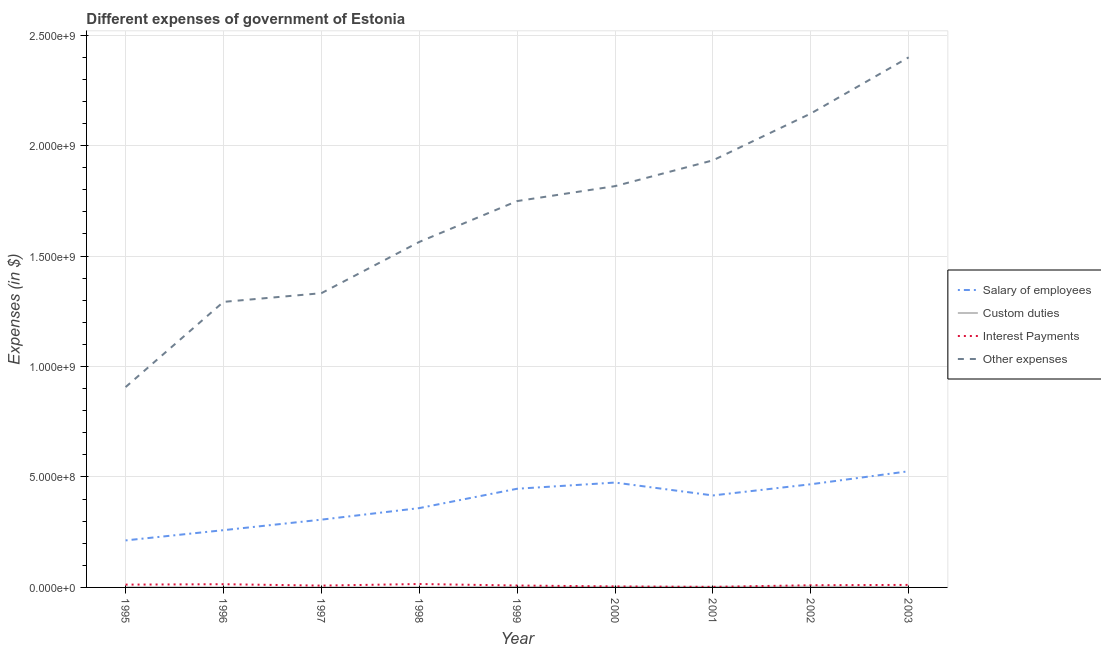How many different coloured lines are there?
Provide a succinct answer. 4. What is the amount spent on other expenses in 1995?
Offer a terse response. 9.07e+08. Across all years, what is the maximum amount spent on interest payments?
Provide a short and direct response. 1.54e+07. Across all years, what is the minimum amount spent on other expenses?
Make the answer very short. 9.07e+08. In which year was the amount spent on custom duties maximum?
Your answer should be very brief. 2002. In which year was the amount spent on custom duties minimum?
Your response must be concise. 1998. What is the total amount spent on custom duties in the graph?
Keep it short and to the point. 1.20e+07. What is the difference between the amount spent on other expenses in 1996 and that in 2000?
Offer a terse response. -5.24e+08. What is the difference between the amount spent on custom duties in 2002 and the amount spent on salary of employees in 1997?
Provide a succinct answer. -3.03e+08. What is the average amount spent on salary of employees per year?
Offer a terse response. 3.85e+08. In the year 2000, what is the difference between the amount spent on salary of employees and amount spent on other expenses?
Provide a succinct answer. -1.34e+09. In how many years, is the amount spent on interest payments greater than 800000000 $?
Keep it short and to the point. 0. What is the ratio of the amount spent on other expenses in 1996 to that in 1998?
Keep it short and to the point. 0.83. What is the difference between the highest and the second highest amount spent on custom duties?
Make the answer very short. 8.50e+05. What is the difference between the highest and the lowest amount spent on other expenses?
Give a very brief answer. 1.49e+09. Is it the case that in every year, the sum of the amount spent on salary of employees and amount spent on interest payments is greater than the sum of amount spent on custom duties and amount spent on other expenses?
Your answer should be very brief. No. Is it the case that in every year, the sum of the amount spent on salary of employees and amount spent on custom duties is greater than the amount spent on interest payments?
Make the answer very short. Yes. Does the amount spent on other expenses monotonically increase over the years?
Your answer should be very brief. Yes. Is the amount spent on interest payments strictly less than the amount spent on other expenses over the years?
Provide a short and direct response. Yes. How many lines are there?
Keep it short and to the point. 4. How many years are there in the graph?
Keep it short and to the point. 9. What is the difference between two consecutive major ticks on the Y-axis?
Make the answer very short. 5.00e+08. Are the values on the major ticks of Y-axis written in scientific E-notation?
Your answer should be very brief. Yes. Does the graph contain grids?
Offer a terse response. Yes. Where does the legend appear in the graph?
Your answer should be compact. Center right. What is the title of the graph?
Make the answer very short. Different expenses of government of Estonia. Does "Primary schools" appear as one of the legend labels in the graph?
Give a very brief answer. No. What is the label or title of the X-axis?
Your answer should be compact. Year. What is the label or title of the Y-axis?
Provide a succinct answer. Expenses (in $). What is the Expenses (in $) of Salary of employees in 1995?
Provide a short and direct response. 2.13e+08. What is the Expenses (in $) of Interest Payments in 1995?
Ensure brevity in your answer.  1.27e+07. What is the Expenses (in $) in Other expenses in 1995?
Give a very brief answer. 9.07e+08. What is the Expenses (in $) of Salary of employees in 1996?
Provide a succinct answer. 2.59e+08. What is the Expenses (in $) of Interest Payments in 1996?
Provide a succinct answer. 1.45e+07. What is the Expenses (in $) in Other expenses in 1996?
Your response must be concise. 1.29e+09. What is the Expenses (in $) in Salary of employees in 1997?
Keep it short and to the point. 3.07e+08. What is the Expenses (in $) of Custom duties in 1997?
Your answer should be compact. 4.00e+04. What is the Expenses (in $) in Interest Payments in 1997?
Give a very brief answer. 8.30e+06. What is the Expenses (in $) in Other expenses in 1997?
Give a very brief answer. 1.33e+09. What is the Expenses (in $) of Salary of employees in 1998?
Your answer should be very brief. 3.59e+08. What is the Expenses (in $) in Custom duties in 1998?
Make the answer very short. 10000. What is the Expenses (in $) of Interest Payments in 1998?
Give a very brief answer. 1.54e+07. What is the Expenses (in $) of Other expenses in 1998?
Give a very brief answer. 1.56e+09. What is the Expenses (in $) of Salary of employees in 1999?
Keep it short and to the point. 4.47e+08. What is the Expenses (in $) in Custom duties in 1999?
Your answer should be very brief. 2.26e+06. What is the Expenses (in $) of Interest Payments in 1999?
Ensure brevity in your answer.  8.70e+06. What is the Expenses (in $) in Other expenses in 1999?
Make the answer very short. 1.75e+09. What is the Expenses (in $) of Salary of employees in 2000?
Give a very brief answer. 4.75e+08. What is the Expenses (in $) in Custom duties in 2000?
Ensure brevity in your answer.  2.56e+06. What is the Expenses (in $) in Interest Payments in 2000?
Give a very brief answer. 4.60e+06. What is the Expenses (in $) of Other expenses in 2000?
Provide a succinct answer. 1.82e+09. What is the Expenses (in $) in Salary of employees in 2001?
Offer a very short reply. 4.16e+08. What is the Expenses (in $) in Custom duties in 2001?
Your response must be concise. 2.45e+06. What is the Expenses (in $) of Interest Payments in 2001?
Offer a terse response. 2.60e+06. What is the Expenses (in $) of Other expenses in 2001?
Ensure brevity in your answer.  1.93e+09. What is the Expenses (in $) of Salary of employees in 2002?
Provide a succinct answer. 4.67e+08. What is the Expenses (in $) in Custom duties in 2002?
Keep it short and to the point. 3.41e+06. What is the Expenses (in $) of Interest Payments in 2002?
Make the answer very short. 1.00e+07. What is the Expenses (in $) of Other expenses in 2002?
Your answer should be compact. 2.15e+09. What is the Expenses (in $) in Salary of employees in 2003?
Your answer should be very brief. 5.26e+08. What is the Expenses (in $) of Custom duties in 2003?
Your answer should be compact. 7.80e+05. What is the Expenses (in $) in Interest Payments in 2003?
Provide a succinct answer. 1.14e+07. What is the Expenses (in $) of Other expenses in 2003?
Your response must be concise. 2.40e+09. Across all years, what is the maximum Expenses (in $) of Salary of employees?
Your answer should be compact. 5.26e+08. Across all years, what is the maximum Expenses (in $) in Custom duties?
Your answer should be compact. 3.41e+06. Across all years, what is the maximum Expenses (in $) of Interest Payments?
Your response must be concise. 1.54e+07. Across all years, what is the maximum Expenses (in $) of Other expenses?
Offer a terse response. 2.40e+09. Across all years, what is the minimum Expenses (in $) in Salary of employees?
Provide a short and direct response. 2.13e+08. Across all years, what is the minimum Expenses (in $) in Custom duties?
Provide a succinct answer. 10000. Across all years, what is the minimum Expenses (in $) of Interest Payments?
Give a very brief answer. 2.60e+06. Across all years, what is the minimum Expenses (in $) in Other expenses?
Your answer should be compact. 9.07e+08. What is the total Expenses (in $) in Salary of employees in the graph?
Your answer should be very brief. 3.47e+09. What is the total Expenses (in $) in Custom duties in the graph?
Offer a terse response. 1.20e+07. What is the total Expenses (in $) of Interest Payments in the graph?
Your response must be concise. 8.82e+07. What is the total Expenses (in $) of Other expenses in the graph?
Provide a short and direct response. 1.51e+1. What is the difference between the Expenses (in $) in Salary of employees in 1995 and that in 1996?
Ensure brevity in your answer.  -4.64e+07. What is the difference between the Expenses (in $) in Interest Payments in 1995 and that in 1996?
Offer a terse response. -1.80e+06. What is the difference between the Expenses (in $) in Other expenses in 1995 and that in 1996?
Your answer should be very brief. -3.86e+08. What is the difference between the Expenses (in $) of Salary of employees in 1995 and that in 1997?
Your response must be concise. -9.40e+07. What is the difference between the Expenses (in $) in Custom duties in 1995 and that in 1997?
Provide a succinct answer. 4.60e+05. What is the difference between the Expenses (in $) in Interest Payments in 1995 and that in 1997?
Your response must be concise. 4.40e+06. What is the difference between the Expenses (in $) of Other expenses in 1995 and that in 1997?
Keep it short and to the point. -4.25e+08. What is the difference between the Expenses (in $) in Salary of employees in 1995 and that in 1998?
Offer a terse response. -1.46e+08. What is the difference between the Expenses (in $) of Custom duties in 1995 and that in 1998?
Provide a succinct answer. 4.90e+05. What is the difference between the Expenses (in $) in Interest Payments in 1995 and that in 1998?
Your answer should be very brief. -2.70e+06. What is the difference between the Expenses (in $) of Other expenses in 1995 and that in 1998?
Offer a very short reply. -6.57e+08. What is the difference between the Expenses (in $) of Salary of employees in 1995 and that in 1999?
Keep it short and to the point. -2.34e+08. What is the difference between the Expenses (in $) of Custom duties in 1995 and that in 1999?
Provide a succinct answer. -1.76e+06. What is the difference between the Expenses (in $) of Other expenses in 1995 and that in 1999?
Give a very brief answer. -8.42e+08. What is the difference between the Expenses (in $) of Salary of employees in 1995 and that in 2000?
Ensure brevity in your answer.  -2.62e+08. What is the difference between the Expenses (in $) of Custom duties in 1995 and that in 2000?
Offer a very short reply. -2.06e+06. What is the difference between the Expenses (in $) in Interest Payments in 1995 and that in 2000?
Keep it short and to the point. 8.10e+06. What is the difference between the Expenses (in $) of Other expenses in 1995 and that in 2000?
Keep it short and to the point. -9.10e+08. What is the difference between the Expenses (in $) of Salary of employees in 1995 and that in 2001?
Make the answer very short. -2.04e+08. What is the difference between the Expenses (in $) in Custom duties in 1995 and that in 2001?
Offer a very short reply. -1.95e+06. What is the difference between the Expenses (in $) in Interest Payments in 1995 and that in 2001?
Make the answer very short. 1.01e+07. What is the difference between the Expenses (in $) of Other expenses in 1995 and that in 2001?
Keep it short and to the point. -1.03e+09. What is the difference between the Expenses (in $) in Salary of employees in 1995 and that in 2002?
Your response must be concise. -2.54e+08. What is the difference between the Expenses (in $) in Custom duties in 1995 and that in 2002?
Your answer should be very brief. -2.91e+06. What is the difference between the Expenses (in $) in Interest Payments in 1995 and that in 2002?
Your answer should be very brief. 2.70e+06. What is the difference between the Expenses (in $) of Other expenses in 1995 and that in 2002?
Offer a very short reply. -1.24e+09. What is the difference between the Expenses (in $) of Salary of employees in 1995 and that in 2003?
Give a very brief answer. -3.13e+08. What is the difference between the Expenses (in $) in Custom duties in 1995 and that in 2003?
Your answer should be very brief. -2.80e+05. What is the difference between the Expenses (in $) in Interest Payments in 1995 and that in 2003?
Keep it short and to the point. 1.30e+06. What is the difference between the Expenses (in $) of Other expenses in 1995 and that in 2003?
Ensure brevity in your answer.  -1.49e+09. What is the difference between the Expenses (in $) in Salary of employees in 1996 and that in 1997?
Provide a short and direct response. -4.76e+07. What is the difference between the Expenses (in $) in Custom duties in 1996 and that in 1997?
Offer a very short reply. -10000. What is the difference between the Expenses (in $) of Interest Payments in 1996 and that in 1997?
Provide a succinct answer. 6.20e+06. What is the difference between the Expenses (in $) in Other expenses in 1996 and that in 1997?
Offer a very short reply. -3.93e+07. What is the difference between the Expenses (in $) of Salary of employees in 1996 and that in 1998?
Make the answer very short. -9.99e+07. What is the difference between the Expenses (in $) of Custom duties in 1996 and that in 1998?
Provide a succinct answer. 2.00e+04. What is the difference between the Expenses (in $) in Interest Payments in 1996 and that in 1998?
Provide a short and direct response. -9.00e+05. What is the difference between the Expenses (in $) of Other expenses in 1996 and that in 1998?
Your response must be concise. -2.71e+08. What is the difference between the Expenses (in $) in Salary of employees in 1996 and that in 1999?
Your response must be concise. -1.88e+08. What is the difference between the Expenses (in $) in Custom duties in 1996 and that in 1999?
Keep it short and to the point. -2.23e+06. What is the difference between the Expenses (in $) in Interest Payments in 1996 and that in 1999?
Your response must be concise. 5.80e+06. What is the difference between the Expenses (in $) of Other expenses in 1996 and that in 1999?
Your response must be concise. -4.56e+08. What is the difference between the Expenses (in $) of Salary of employees in 1996 and that in 2000?
Provide a short and direct response. -2.16e+08. What is the difference between the Expenses (in $) of Custom duties in 1996 and that in 2000?
Keep it short and to the point. -2.53e+06. What is the difference between the Expenses (in $) in Interest Payments in 1996 and that in 2000?
Give a very brief answer. 9.90e+06. What is the difference between the Expenses (in $) of Other expenses in 1996 and that in 2000?
Offer a terse response. -5.24e+08. What is the difference between the Expenses (in $) in Salary of employees in 1996 and that in 2001?
Provide a succinct answer. -1.57e+08. What is the difference between the Expenses (in $) of Custom duties in 1996 and that in 2001?
Offer a terse response. -2.42e+06. What is the difference between the Expenses (in $) in Interest Payments in 1996 and that in 2001?
Make the answer very short. 1.19e+07. What is the difference between the Expenses (in $) of Other expenses in 1996 and that in 2001?
Ensure brevity in your answer.  -6.41e+08. What is the difference between the Expenses (in $) of Salary of employees in 1996 and that in 2002?
Your answer should be compact. -2.08e+08. What is the difference between the Expenses (in $) of Custom duties in 1996 and that in 2002?
Ensure brevity in your answer.  -3.38e+06. What is the difference between the Expenses (in $) in Interest Payments in 1996 and that in 2002?
Offer a very short reply. 4.50e+06. What is the difference between the Expenses (in $) of Other expenses in 1996 and that in 2002?
Ensure brevity in your answer.  -8.53e+08. What is the difference between the Expenses (in $) of Salary of employees in 1996 and that in 2003?
Your answer should be compact. -2.67e+08. What is the difference between the Expenses (in $) of Custom duties in 1996 and that in 2003?
Your answer should be compact. -7.50e+05. What is the difference between the Expenses (in $) in Interest Payments in 1996 and that in 2003?
Your answer should be compact. 3.10e+06. What is the difference between the Expenses (in $) of Other expenses in 1996 and that in 2003?
Provide a succinct answer. -1.11e+09. What is the difference between the Expenses (in $) of Salary of employees in 1997 and that in 1998?
Provide a succinct answer. -5.23e+07. What is the difference between the Expenses (in $) of Interest Payments in 1997 and that in 1998?
Make the answer very short. -7.10e+06. What is the difference between the Expenses (in $) of Other expenses in 1997 and that in 1998?
Your answer should be very brief. -2.32e+08. What is the difference between the Expenses (in $) of Salary of employees in 1997 and that in 1999?
Offer a very short reply. -1.40e+08. What is the difference between the Expenses (in $) in Custom duties in 1997 and that in 1999?
Offer a very short reply. -2.22e+06. What is the difference between the Expenses (in $) of Interest Payments in 1997 and that in 1999?
Ensure brevity in your answer.  -4.00e+05. What is the difference between the Expenses (in $) in Other expenses in 1997 and that in 1999?
Ensure brevity in your answer.  -4.17e+08. What is the difference between the Expenses (in $) in Salary of employees in 1997 and that in 2000?
Offer a very short reply. -1.68e+08. What is the difference between the Expenses (in $) of Custom duties in 1997 and that in 2000?
Ensure brevity in your answer.  -2.52e+06. What is the difference between the Expenses (in $) of Interest Payments in 1997 and that in 2000?
Offer a very short reply. 3.70e+06. What is the difference between the Expenses (in $) of Other expenses in 1997 and that in 2000?
Offer a terse response. -4.85e+08. What is the difference between the Expenses (in $) of Salary of employees in 1997 and that in 2001?
Provide a short and direct response. -1.10e+08. What is the difference between the Expenses (in $) of Custom duties in 1997 and that in 2001?
Keep it short and to the point. -2.41e+06. What is the difference between the Expenses (in $) in Interest Payments in 1997 and that in 2001?
Your response must be concise. 5.70e+06. What is the difference between the Expenses (in $) of Other expenses in 1997 and that in 2001?
Provide a succinct answer. -6.01e+08. What is the difference between the Expenses (in $) in Salary of employees in 1997 and that in 2002?
Ensure brevity in your answer.  -1.60e+08. What is the difference between the Expenses (in $) of Custom duties in 1997 and that in 2002?
Provide a succinct answer. -3.37e+06. What is the difference between the Expenses (in $) of Interest Payments in 1997 and that in 2002?
Keep it short and to the point. -1.70e+06. What is the difference between the Expenses (in $) of Other expenses in 1997 and that in 2002?
Make the answer very short. -8.13e+08. What is the difference between the Expenses (in $) of Salary of employees in 1997 and that in 2003?
Offer a terse response. -2.19e+08. What is the difference between the Expenses (in $) of Custom duties in 1997 and that in 2003?
Your answer should be compact. -7.40e+05. What is the difference between the Expenses (in $) in Interest Payments in 1997 and that in 2003?
Give a very brief answer. -3.10e+06. What is the difference between the Expenses (in $) of Other expenses in 1997 and that in 2003?
Make the answer very short. -1.07e+09. What is the difference between the Expenses (in $) of Salary of employees in 1998 and that in 1999?
Ensure brevity in your answer.  -8.76e+07. What is the difference between the Expenses (in $) in Custom duties in 1998 and that in 1999?
Provide a succinct answer. -2.25e+06. What is the difference between the Expenses (in $) of Interest Payments in 1998 and that in 1999?
Your response must be concise. 6.70e+06. What is the difference between the Expenses (in $) in Other expenses in 1998 and that in 1999?
Your answer should be very brief. -1.85e+08. What is the difference between the Expenses (in $) in Salary of employees in 1998 and that in 2000?
Your answer should be very brief. -1.16e+08. What is the difference between the Expenses (in $) of Custom duties in 1998 and that in 2000?
Your answer should be very brief. -2.55e+06. What is the difference between the Expenses (in $) in Interest Payments in 1998 and that in 2000?
Offer a very short reply. 1.08e+07. What is the difference between the Expenses (in $) of Other expenses in 1998 and that in 2000?
Your answer should be compact. -2.53e+08. What is the difference between the Expenses (in $) in Salary of employees in 1998 and that in 2001?
Your response must be concise. -5.73e+07. What is the difference between the Expenses (in $) in Custom duties in 1998 and that in 2001?
Keep it short and to the point. -2.44e+06. What is the difference between the Expenses (in $) in Interest Payments in 1998 and that in 2001?
Make the answer very short. 1.28e+07. What is the difference between the Expenses (in $) in Other expenses in 1998 and that in 2001?
Your answer should be compact. -3.69e+08. What is the difference between the Expenses (in $) in Salary of employees in 1998 and that in 2002?
Ensure brevity in your answer.  -1.08e+08. What is the difference between the Expenses (in $) in Custom duties in 1998 and that in 2002?
Keep it short and to the point. -3.40e+06. What is the difference between the Expenses (in $) in Interest Payments in 1998 and that in 2002?
Give a very brief answer. 5.40e+06. What is the difference between the Expenses (in $) of Other expenses in 1998 and that in 2002?
Your answer should be compact. -5.81e+08. What is the difference between the Expenses (in $) in Salary of employees in 1998 and that in 2003?
Ensure brevity in your answer.  -1.67e+08. What is the difference between the Expenses (in $) of Custom duties in 1998 and that in 2003?
Your answer should be very brief. -7.70e+05. What is the difference between the Expenses (in $) of Other expenses in 1998 and that in 2003?
Your answer should be very brief. -8.36e+08. What is the difference between the Expenses (in $) of Salary of employees in 1999 and that in 2000?
Give a very brief answer. -2.80e+07. What is the difference between the Expenses (in $) of Custom duties in 1999 and that in 2000?
Your response must be concise. -3.00e+05. What is the difference between the Expenses (in $) in Interest Payments in 1999 and that in 2000?
Provide a short and direct response. 4.10e+06. What is the difference between the Expenses (in $) in Other expenses in 1999 and that in 2000?
Your answer should be compact. -6.76e+07. What is the difference between the Expenses (in $) in Salary of employees in 1999 and that in 2001?
Your answer should be very brief. 3.03e+07. What is the difference between the Expenses (in $) of Interest Payments in 1999 and that in 2001?
Your answer should be compact. 6.10e+06. What is the difference between the Expenses (in $) in Other expenses in 1999 and that in 2001?
Provide a short and direct response. -1.84e+08. What is the difference between the Expenses (in $) in Salary of employees in 1999 and that in 2002?
Ensure brevity in your answer.  -2.03e+07. What is the difference between the Expenses (in $) in Custom duties in 1999 and that in 2002?
Offer a very short reply. -1.15e+06. What is the difference between the Expenses (in $) in Interest Payments in 1999 and that in 2002?
Offer a very short reply. -1.30e+06. What is the difference between the Expenses (in $) in Other expenses in 1999 and that in 2002?
Your response must be concise. -3.96e+08. What is the difference between the Expenses (in $) in Salary of employees in 1999 and that in 2003?
Your response must be concise. -7.92e+07. What is the difference between the Expenses (in $) of Custom duties in 1999 and that in 2003?
Offer a very short reply. 1.48e+06. What is the difference between the Expenses (in $) of Interest Payments in 1999 and that in 2003?
Ensure brevity in your answer.  -2.70e+06. What is the difference between the Expenses (in $) of Other expenses in 1999 and that in 2003?
Your response must be concise. -6.51e+08. What is the difference between the Expenses (in $) in Salary of employees in 2000 and that in 2001?
Make the answer very short. 5.83e+07. What is the difference between the Expenses (in $) in Custom duties in 2000 and that in 2001?
Give a very brief answer. 1.10e+05. What is the difference between the Expenses (in $) in Interest Payments in 2000 and that in 2001?
Your response must be concise. 2.00e+06. What is the difference between the Expenses (in $) of Other expenses in 2000 and that in 2001?
Provide a short and direct response. -1.17e+08. What is the difference between the Expenses (in $) of Salary of employees in 2000 and that in 2002?
Keep it short and to the point. 7.70e+06. What is the difference between the Expenses (in $) of Custom duties in 2000 and that in 2002?
Offer a terse response. -8.50e+05. What is the difference between the Expenses (in $) of Interest Payments in 2000 and that in 2002?
Keep it short and to the point. -5.40e+06. What is the difference between the Expenses (in $) in Other expenses in 2000 and that in 2002?
Your answer should be very brief. -3.29e+08. What is the difference between the Expenses (in $) of Salary of employees in 2000 and that in 2003?
Keep it short and to the point. -5.12e+07. What is the difference between the Expenses (in $) in Custom duties in 2000 and that in 2003?
Provide a succinct answer. 1.78e+06. What is the difference between the Expenses (in $) in Interest Payments in 2000 and that in 2003?
Your answer should be very brief. -6.80e+06. What is the difference between the Expenses (in $) of Other expenses in 2000 and that in 2003?
Make the answer very short. -5.83e+08. What is the difference between the Expenses (in $) of Salary of employees in 2001 and that in 2002?
Your answer should be very brief. -5.06e+07. What is the difference between the Expenses (in $) of Custom duties in 2001 and that in 2002?
Provide a short and direct response. -9.60e+05. What is the difference between the Expenses (in $) of Interest Payments in 2001 and that in 2002?
Ensure brevity in your answer.  -7.40e+06. What is the difference between the Expenses (in $) of Other expenses in 2001 and that in 2002?
Make the answer very short. -2.12e+08. What is the difference between the Expenses (in $) in Salary of employees in 2001 and that in 2003?
Offer a terse response. -1.10e+08. What is the difference between the Expenses (in $) of Custom duties in 2001 and that in 2003?
Your response must be concise. 1.67e+06. What is the difference between the Expenses (in $) of Interest Payments in 2001 and that in 2003?
Offer a very short reply. -8.80e+06. What is the difference between the Expenses (in $) in Other expenses in 2001 and that in 2003?
Your answer should be very brief. -4.66e+08. What is the difference between the Expenses (in $) of Salary of employees in 2002 and that in 2003?
Your answer should be compact. -5.89e+07. What is the difference between the Expenses (in $) in Custom duties in 2002 and that in 2003?
Your answer should be very brief. 2.63e+06. What is the difference between the Expenses (in $) in Interest Payments in 2002 and that in 2003?
Ensure brevity in your answer.  -1.40e+06. What is the difference between the Expenses (in $) in Other expenses in 2002 and that in 2003?
Your answer should be compact. -2.54e+08. What is the difference between the Expenses (in $) of Salary of employees in 1995 and the Expenses (in $) of Custom duties in 1996?
Offer a very short reply. 2.13e+08. What is the difference between the Expenses (in $) of Salary of employees in 1995 and the Expenses (in $) of Interest Payments in 1996?
Your answer should be compact. 1.98e+08. What is the difference between the Expenses (in $) of Salary of employees in 1995 and the Expenses (in $) of Other expenses in 1996?
Keep it short and to the point. -1.08e+09. What is the difference between the Expenses (in $) of Custom duties in 1995 and the Expenses (in $) of Interest Payments in 1996?
Offer a very short reply. -1.40e+07. What is the difference between the Expenses (in $) of Custom duties in 1995 and the Expenses (in $) of Other expenses in 1996?
Offer a terse response. -1.29e+09. What is the difference between the Expenses (in $) in Interest Payments in 1995 and the Expenses (in $) in Other expenses in 1996?
Make the answer very short. -1.28e+09. What is the difference between the Expenses (in $) in Salary of employees in 1995 and the Expenses (in $) in Custom duties in 1997?
Provide a short and direct response. 2.13e+08. What is the difference between the Expenses (in $) of Salary of employees in 1995 and the Expenses (in $) of Interest Payments in 1997?
Offer a very short reply. 2.04e+08. What is the difference between the Expenses (in $) of Salary of employees in 1995 and the Expenses (in $) of Other expenses in 1997?
Keep it short and to the point. -1.12e+09. What is the difference between the Expenses (in $) in Custom duties in 1995 and the Expenses (in $) in Interest Payments in 1997?
Ensure brevity in your answer.  -7.80e+06. What is the difference between the Expenses (in $) of Custom duties in 1995 and the Expenses (in $) of Other expenses in 1997?
Provide a succinct answer. -1.33e+09. What is the difference between the Expenses (in $) in Interest Payments in 1995 and the Expenses (in $) in Other expenses in 1997?
Offer a terse response. -1.32e+09. What is the difference between the Expenses (in $) of Salary of employees in 1995 and the Expenses (in $) of Custom duties in 1998?
Offer a very short reply. 2.13e+08. What is the difference between the Expenses (in $) of Salary of employees in 1995 and the Expenses (in $) of Interest Payments in 1998?
Offer a terse response. 1.97e+08. What is the difference between the Expenses (in $) of Salary of employees in 1995 and the Expenses (in $) of Other expenses in 1998?
Offer a very short reply. -1.35e+09. What is the difference between the Expenses (in $) in Custom duties in 1995 and the Expenses (in $) in Interest Payments in 1998?
Ensure brevity in your answer.  -1.49e+07. What is the difference between the Expenses (in $) in Custom duties in 1995 and the Expenses (in $) in Other expenses in 1998?
Offer a very short reply. -1.56e+09. What is the difference between the Expenses (in $) of Interest Payments in 1995 and the Expenses (in $) of Other expenses in 1998?
Keep it short and to the point. -1.55e+09. What is the difference between the Expenses (in $) in Salary of employees in 1995 and the Expenses (in $) in Custom duties in 1999?
Provide a short and direct response. 2.11e+08. What is the difference between the Expenses (in $) in Salary of employees in 1995 and the Expenses (in $) in Interest Payments in 1999?
Your answer should be very brief. 2.04e+08. What is the difference between the Expenses (in $) of Salary of employees in 1995 and the Expenses (in $) of Other expenses in 1999?
Provide a short and direct response. -1.54e+09. What is the difference between the Expenses (in $) in Custom duties in 1995 and the Expenses (in $) in Interest Payments in 1999?
Make the answer very short. -8.20e+06. What is the difference between the Expenses (in $) of Custom duties in 1995 and the Expenses (in $) of Other expenses in 1999?
Make the answer very short. -1.75e+09. What is the difference between the Expenses (in $) of Interest Payments in 1995 and the Expenses (in $) of Other expenses in 1999?
Give a very brief answer. -1.74e+09. What is the difference between the Expenses (in $) in Salary of employees in 1995 and the Expenses (in $) in Custom duties in 2000?
Give a very brief answer. 2.10e+08. What is the difference between the Expenses (in $) in Salary of employees in 1995 and the Expenses (in $) in Interest Payments in 2000?
Your answer should be very brief. 2.08e+08. What is the difference between the Expenses (in $) in Salary of employees in 1995 and the Expenses (in $) in Other expenses in 2000?
Ensure brevity in your answer.  -1.60e+09. What is the difference between the Expenses (in $) of Custom duties in 1995 and the Expenses (in $) of Interest Payments in 2000?
Give a very brief answer. -4.10e+06. What is the difference between the Expenses (in $) in Custom duties in 1995 and the Expenses (in $) in Other expenses in 2000?
Make the answer very short. -1.82e+09. What is the difference between the Expenses (in $) in Interest Payments in 1995 and the Expenses (in $) in Other expenses in 2000?
Ensure brevity in your answer.  -1.80e+09. What is the difference between the Expenses (in $) in Salary of employees in 1995 and the Expenses (in $) in Custom duties in 2001?
Your answer should be compact. 2.10e+08. What is the difference between the Expenses (in $) of Salary of employees in 1995 and the Expenses (in $) of Interest Payments in 2001?
Ensure brevity in your answer.  2.10e+08. What is the difference between the Expenses (in $) in Salary of employees in 1995 and the Expenses (in $) in Other expenses in 2001?
Provide a short and direct response. -1.72e+09. What is the difference between the Expenses (in $) in Custom duties in 1995 and the Expenses (in $) in Interest Payments in 2001?
Your answer should be very brief. -2.10e+06. What is the difference between the Expenses (in $) of Custom duties in 1995 and the Expenses (in $) of Other expenses in 2001?
Your response must be concise. -1.93e+09. What is the difference between the Expenses (in $) in Interest Payments in 1995 and the Expenses (in $) in Other expenses in 2001?
Your answer should be very brief. -1.92e+09. What is the difference between the Expenses (in $) in Salary of employees in 1995 and the Expenses (in $) in Custom duties in 2002?
Keep it short and to the point. 2.09e+08. What is the difference between the Expenses (in $) of Salary of employees in 1995 and the Expenses (in $) of Interest Payments in 2002?
Offer a terse response. 2.03e+08. What is the difference between the Expenses (in $) of Salary of employees in 1995 and the Expenses (in $) of Other expenses in 2002?
Your answer should be very brief. -1.93e+09. What is the difference between the Expenses (in $) in Custom duties in 1995 and the Expenses (in $) in Interest Payments in 2002?
Offer a very short reply. -9.50e+06. What is the difference between the Expenses (in $) in Custom duties in 1995 and the Expenses (in $) in Other expenses in 2002?
Your answer should be very brief. -2.14e+09. What is the difference between the Expenses (in $) of Interest Payments in 1995 and the Expenses (in $) of Other expenses in 2002?
Keep it short and to the point. -2.13e+09. What is the difference between the Expenses (in $) in Salary of employees in 1995 and the Expenses (in $) in Custom duties in 2003?
Offer a terse response. 2.12e+08. What is the difference between the Expenses (in $) of Salary of employees in 1995 and the Expenses (in $) of Interest Payments in 2003?
Offer a terse response. 2.01e+08. What is the difference between the Expenses (in $) in Salary of employees in 1995 and the Expenses (in $) in Other expenses in 2003?
Your response must be concise. -2.19e+09. What is the difference between the Expenses (in $) in Custom duties in 1995 and the Expenses (in $) in Interest Payments in 2003?
Give a very brief answer. -1.09e+07. What is the difference between the Expenses (in $) in Custom duties in 1995 and the Expenses (in $) in Other expenses in 2003?
Your answer should be compact. -2.40e+09. What is the difference between the Expenses (in $) of Interest Payments in 1995 and the Expenses (in $) of Other expenses in 2003?
Offer a terse response. -2.39e+09. What is the difference between the Expenses (in $) in Salary of employees in 1996 and the Expenses (in $) in Custom duties in 1997?
Provide a short and direct response. 2.59e+08. What is the difference between the Expenses (in $) in Salary of employees in 1996 and the Expenses (in $) in Interest Payments in 1997?
Offer a terse response. 2.51e+08. What is the difference between the Expenses (in $) in Salary of employees in 1996 and the Expenses (in $) in Other expenses in 1997?
Your answer should be very brief. -1.07e+09. What is the difference between the Expenses (in $) in Custom duties in 1996 and the Expenses (in $) in Interest Payments in 1997?
Your answer should be very brief. -8.27e+06. What is the difference between the Expenses (in $) of Custom duties in 1996 and the Expenses (in $) of Other expenses in 1997?
Your answer should be very brief. -1.33e+09. What is the difference between the Expenses (in $) of Interest Payments in 1996 and the Expenses (in $) of Other expenses in 1997?
Provide a short and direct response. -1.32e+09. What is the difference between the Expenses (in $) in Salary of employees in 1996 and the Expenses (in $) in Custom duties in 1998?
Offer a very short reply. 2.59e+08. What is the difference between the Expenses (in $) in Salary of employees in 1996 and the Expenses (in $) in Interest Payments in 1998?
Offer a very short reply. 2.44e+08. What is the difference between the Expenses (in $) in Salary of employees in 1996 and the Expenses (in $) in Other expenses in 1998?
Provide a succinct answer. -1.30e+09. What is the difference between the Expenses (in $) in Custom duties in 1996 and the Expenses (in $) in Interest Payments in 1998?
Offer a very short reply. -1.54e+07. What is the difference between the Expenses (in $) in Custom duties in 1996 and the Expenses (in $) in Other expenses in 1998?
Provide a short and direct response. -1.56e+09. What is the difference between the Expenses (in $) in Interest Payments in 1996 and the Expenses (in $) in Other expenses in 1998?
Keep it short and to the point. -1.55e+09. What is the difference between the Expenses (in $) of Salary of employees in 1996 and the Expenses (in $) of Custom duties in 1999?
Offer a very short reply. 2.57e+08. What is the difference between the Expenses (in $) of Salary of employees in 1996 and the Expenses (in $) of Interest Payments in 1999?
Keep it short and to the point. 2.50e+08. What is the difference between the Expenses (in $) of Salary of employees in 1996 and the Expenses (in $) of Other expenses in 1999?
Offer a terse response. -1.49e+09. What is the difference between the Expenses (in $) of Custom duties in 1996 and the Expenses (in $) of Interest Payments in 1999?
Keep it short and to the point. -8.67e+06. What is the difference between the Expenses (in $) in Custom duties in 1996 and the Expenses (in $) in Other expenses in 1999?
Make the answer very short. -1.75e+09. What is the difference between the Expenses (in $) in Interest Payments in 1996 and the Expenses (in $) in Other expenses in 1999?
Your answer should be compact. -1.73e+09. What is the difference between the Expenses (in $) of Salary of employees in 1996 and the Expenses (in $) of Custom duties in 2000?
Provide a short and direct response. 2.57e+08. What is the difference between the Expenses (in $) in Salary of employees in 1996 and the Expenses (in $) in Interest Payments in 2000?
Give a very brief answer. 2.55e+08. What is the difference between the Expenses (in $) of Salary of employees in 1996 and the Expenses (in $) of Other expenses in 2000?
Keep it short and to the point. -1.56e+09. What is the difference between the Expenses (in $) in Custom duties in 1996 and the Expenses (in $) in Interest Payments in 2000?
Offer a very short reply. -4.57e+06. What is the difference between the Expenses (in $) in Custom duties in 1996 and the Expenses (in $) in Other expenses in 2000?
Offer a terse response. -1.82e+09. What is the difference between the Expenses (in $) of Interest Payments in 1996 and the Expenses (in $) of Other expenses in 2000?
Ensure brevity in your answer.  -1.80e+09. What is the difference between the Expenses (in $) in Salary of employees in 1996 and the Expenses (in $) in Custom duties in 2001?
Ensure brevity in your answer.  2.57e+08. What is the difference between the Expenses (in $) in Salary of employees in 1996 and the Expenses (in $) in Interest Payments in 2001?
Give a very brief answer. 2.57e+08. What is the difference between the Expenses (in $) of Salary of employees in 1996 and the Expenses (in $) of Other expenses in 2001?
Offer a terse response. -1.67e+09. What is the difference between the Expenses (in $) of Custom duties in 1996 and the Expenses (in $) of Interest Payments in 2001?
Offer a terse response. -2.57e+06. What is the difference between the Expenses (in $) of Custom duties in 1996 and the Expenses (in $) of Other expenses in 2001?
Give a very brief answer. -1.93e+09. What is the difference between the Expenses (in $) in Interest Payments in 1996 and the Expenses (in $) in Other expenses in 2001?
Provide a succinct answer. -1.92e+09. What is the difference between the Expenses (in $) of Salary of employees in 1996 and the Expenses (in $) of Custom duties in 2002?
Your response must be concise. 2.56e+08. What is the difference between the Expenses (in $) of Salary of employees in 1996 and the Expenses (in $) of Interest Payments in 2002?
Provide a succinct answer. 2.49e+08. What is the difference between the Expenses (in $) in Salary of employees in 1996 and the Expenses (in $) in Other expenses in 2002?
Your response must be concise. -1.89e+09. What is the difference between the Expenses (in $) of Custom duties in 1996 and the Expenses (in $) of Interest Payments in 2002?
Offer a very short reply. -9.97e+06. What is the difference between the Expenses (in $) in Custom duties in 1996 and the Expenses (in $) in Other expenses in 2002?
Provide a succinct answer. -2.15e+09. What is the difference between the Expenses (in $) in Interest Payments in 1996 and the Expenses (in $) in Other expenses in 2002?
Offer a terse response. -2.13e+09. What is the difference between the Expenses (in $) in Salary of employees in 1996 and the Expenses (in $) in Custom duties in 2003?
Give a very brief answer. 2.58e+08. What is the difference between the Expenses (in $) in Salary of employees in 1996 and the Expenses (in $) in Interest Payments in 2003?
Your answer should be compact. 2.48e+08. What is the difference between the Expenses (in $) in Salary of employees in 1996 and the Expenses (in $) in Other expenses in 2003?
Offer a very short reply. -2.14e+09. What is the difference between the Expenses (in $) of Custom duties in 1996 and the Expenses (in $) of Interest Payments in 2003?
Your response must be concise. -1.14e+07. What is the difference between the Expenses (in $) in Custom duties in 1996 and the Expenses (in $) in Other expenses in 2003?
Give a very brief answer. -2.40e+09. What is the difference between the Expenses (in $) of Interest Payments in 1996 and the Expenses (in $) of Other expenses in 2003?
Provide a short and direct response. -2.39e+09. What is the difference between the Expenses (in $) in Salary of employees in 1997 and the Expenses (in $) in Custom duties in 1998?
Make the answer very short. 3.07e+08. What is the difference between the Expenses (in $) in Salary of employees in 1997 and the Expenses (in $) in Interest Payments in 1998?
Offer a terse response. 2.91e+08. What is the difference between the Expenses (in $) in Salary of employees in 1997 and the Expenses (in $) in Other expenses in 1998?
Your answer should be very brief. -1.26e+09. What is the difference between the Expenses (in $) of Custom duties in 1997 and the Expenses (in $) of Interest Payments in 1998?
Provide a short and direct response. -1.54e+07. What is the difference between the Expenses (in $) of Custom duties in 1997 and the Expenses (in $) of Other expenses in 1998?
Ensure brevity in your answer.  -1.56e+09. What is the difference between the Expenses (in $) of Interest Payments in 1997 and the Expenses (in $) of Other expenses in 1998?
Offer a terse response. -1.56e+09. What is the difference between the Expenses (in $) in Salary of employees in 1997 and the Expenses (in $) in Custom duties in 1999?
Offer a terse response. 3.05e+08. What is the difference between the Expenses (in $) in Salary of employees in 1997 and the Expenses (in $) in Interest Payments in 1999?
Keep it short and to the point. 2.98e+08. What is the difference between the Expenses (in $) of Salary of employees in 1997 and the Expenses (in $) of Other expenses in 1999?
Make the answer very short. -1.44e+09. What is the difference between the Expenses (in $) of Custom duties in 1997 and the Expenses (in $) of Interest Payments in 1999?
Offer a very short reply. -8.66e+06. What is the difference between the Expenses (in $) of Custom duties in 1997 and the Expenses (in $) of Other expenses in 1999?
Keep it short and to the point. -1.75e+09. What is the difference between the Expenses (in $) in Interest Payments in 1997 and the Expenses (in $) in Other expenses in 1999?
Provide a short and direct response. -1.74e+09. What is the difference between the Expenses (in $) in Salary of employees in 1997 and the Expenses (in $) in Custom duties in 2000?
Make the answer very short. 3.04e+08. What is the difference between the Expenses (in $) in Salary of employees in 1997 and the Expenses (in $) in Interest Payments in 2000?
Your answer should be very brief. 3.02e+08. What is the difference between the Expenses (in $) of Salary of employees in 1997 and the Expenses (in $) of Other expenses in 2000?
Your answer should be very brief. -1.51e+09. What is the difference between the Expenses (in $) of Custom duties in 1997 and the Expenses (in $) of Interest Payments in 2000?
Offer a very short reply. -4.56e+06. What is the difference between the Expenses (in $) of Custom duties in 1997 and the Expenses (in $) of Other expenses in 2000?
Ensure brevity in your answer.  -1.82e+09. What is the difference between the Expenses (in $) of Interest Payments in 1997 and the Expenses (in $) of Other expenses in 2000?
Your answer should be compact. -1.81e+09. What is the difference between the Expenses (in $) of Salary of employees in 1997 and the Expenses (in $) of Custom duties in 2001?
Keep it short and to the point. 3.04e+08. What is the difference between the Expenses (in $) of Salary of employees in 1997 and the Expenses (in $) of Interest Payments in 2001?
Provide a short and direct response. 3.04e+08. What is the difference between the Expenses (in $) of Salary of employees in 1997 and the Expenses (in $) of Other expenses in 2001?
Your answer should be compact. -1.63e+09. What is the difference between the Expenses (in $) in Custom duties in 1997 and the Expenses (in $) in Interest Payments in 2001?
Give a very brief answer. -2.56e+06. What is the difference between the Expenses (in $) in Custom duties in 1997 and the Expenses (in $) in Other expenses in 2001?
Provide a short and direct response. -1.93e+09. What is the difference between the Expenses (in $) of Interest Payments in 1997 and the Expenses (in $) of Other expenses in 2001?
Your answer should be very brief. -1.92e+09. What is the difference between the Expenses (in $) in Salary of employees in 1997 and the Expenses (in $) in Custom duties in 2002?
Make the answer very short. 3.03e+08. What is the difference between the Expenses (in $) in Salary of employees in 1997 and the Expenses (in $) in Interest Payments in 2002?
Your answer should be compact. 2.97e+08. What is the difference between the Expenses (in $) in Salary of employees in 1997 and the Expenses (in $) in Other expenses in 2002?
Your answer should be compact. -1.84e+09. What is the difference between the Expenses (in $) in Custom duties in 1997 and the Expenses (in $) in Interest Payments in 2002?
Provide a short and direct response. -9.96e+06. What is the difference between the Expenses (in $) of Custom duties in 1997 and the Expenses (in $) of Other expenses in 2002?
Offer a terse response. -2.15e+09. What is the difference between the Expenses (in $) in Interest Payments in 1997 and the Expenses (in $) in Other expenses in 2002?
Make the answer very short. -2.14e+09. What is the difference between the Expenses (in $) of Salary of employees in 1997 and the Expenses (in $) of Custom duties in 2003?
Offer a very short reply. 3.06e+08. What is the difference between the Expenses (in $) of Salary of employees in 1997 and the Expenses (in $) of Interest Payments in 2003?
Provide a succinct answer. 2.95e+08. What is the difference between the Expenses (in $) in Salary of employees in 1997 and the Expenses (in $) in Other expenses in 2003?
Provide a short and direct response. -2.09e+09. What is the difference between the Expenses (in $) in Custom duties in 1997 and the Expenses (in $) in Interest Payments in 2003?
Ensure brevity in your answer.  -1.14e+07. What is the difference between the Expenses (in $) in Custom duties in 1997 and the Expenses (in $) in Other expenses in 2003?
Give a very brief answer. -2.40e+09. What is the difference between the Expenses (in $) in Interest Payments in 1997 and the Expenses (in $) in Other expenses in 2003?
Offer a very short reply. -2.39e+09. What is the difference between the Expenses (in $) of Salary of employees in 1998 and the Expenses (in $) of Custom duties in 1999?
Give a very brief answer. 3.57e+08. What is the difference between the Expenses (in $) of Salary of employees in 1998 and the Expenses (in $) of Interest Payments in 1999?
Your answer should be compact. 3.50e+08. What is the difference between the Expenses (in $) of Salary of employees in 1998 and the Expenses (in $) of Other expenses in 1999?
Offer a terse response. -1.39e+09. What is the difference between the Expenses (in $) in Custom duties in 1998 and the Expenses (in $) in Interest Payments in 1999?
Ensure brevity in your answer.  -8.69e+06. What is the difference between the Expenses (in $) in Custom duties in 1998 and the Expenses (in $) in Other expenses in 1999?
Provide a succinct answer. -1.75e+09. What is the difference between the Expenses (in $) in Interest Payments in 1998 and the Expenses (in $) in Other expenses in 1999?
Ensure brevity in your answer.  -1.73e+09. What is the difference between the Expenses (in $) in Salary of employees in 1998 and the Expenses (in $) in Custom duties in 2000?
Provide a short and direct response. 3.57e+08. What is the difference between the Expenses (in $) in Salary of employees in 1998 and the Expenses (in $) in Interest Payments in 2000?
Provide a succinct answer. 3.54e+08. What is the difference between the Expenses (in $) of Salary of employees in 1998 and the Expenses (in $) of Other expenses in 2000?
Offer a terse response. -1.46e+09. What is the difference between the Expenses (in $) in Custom duties in 1998 and the Expenses (in $) in Interest Payments in 2000?
Provide a succinct answer. -4.59e+06. What is the difference between the Expenses (in $) of Custom duties in 1998 and the Expenses (in $) of Other expenses in 2000?
Keep it short and to the point. -1.82e+09. What is the difference between the Expenses (in $) of Interest Payments in 1998 and the Expenses (in $) of Other expenses in 2000?
Give a very brief answer. -1.80e+09. What is the difference between the Expenses (in $) in Salary of employees in 1998 and the Expenses (in $) in Custom duties in 2001?
Your response must be concise. 3.57e+08. What is the difference between the Expenses (in $) in Salary of employees in 1998 and the Expenses (in $) in Interest Payments in 2001?
Offer a terse response. 3.56e+08. What is the difference between the Expenses (in $) of Salary of employees in 1998 and the Expenses (in $) of Other expenses in 2001?
Give a very brief answer. -1.57e+09. What is the difference between the Expenses (in $) of Custom duties in 1998 and the Expenses (in $) of Interest Payments in 2001?
Provide a succinct answer. -2.59e+06. What is the difference between the Expenses (in $) of Custom duties in 1998 and the Expenses (in $) of Other expenses in 2001?
Offer a terse response. -1.93e+09. What is the difference between the Expenses (in $) in Interest Payments in 1998 and the Expenses (in $) in Other expenses in 2001?
Make the answer very short. -1.92e+09. What is the difference between the Expenses (in $) in Salary of employees in 1998 and the Expenses (in $) in Custom duties in 2002?
Provide a succinct answer. 3.56e+08. What is the difference between the Expenses (in $) in Salary of employees in 1998 and the Expenses (in $) in Interest Payments in 2002?
Offer a very short reply. 3.49e+08. What is the difference between the Expenses (in $) of Salary of employees in 1998 and the Expenses (in $) of Other expenses in 2002?
Your answer should be very brief. -1.79e+09. What is the difference between the Expenses (in $) of Custom duties in 1998 and the Expenses (in $) of Interest Payments in 2002?
Your response must be concise. -9.99e+06. What is the difference between the Expenses (in $) of Custom duties in 1998 and the Expenses (in $) of Other expenses in 2002?
Provide a succinct answer. -2.15e+09. What is the difference between the Expenses (in $) of Interest Payments in 1998 and the Expenses (in $) of Other expenses in 2002?
Offer a very short reply. -2.13e+09. What is the difference between the Expenses (in $) in Salary of employees in 1998 and the Expenses (in $) in Custom duties in 2003?
Provide a short and direct response. 3.58e+08. What is the difference between the Expenses (in $) of Salary of employees in 1998 and the Expenses (in $) of Interest Payments in 2003?
Provide a succinct answer. 3.48e+08. What is the difference between the Expenses (in $) of Salary of employees in 1998 and the Expenses (in $) of Other expenses in 2003?
Your answer should be compact. -2.04e+09. What is the difference between the Expenses (in $) in Custom duties in 1998 and the Expenses (in $) in Interest Payments in 2003?
Keep it short and to the point. -1.14e+07. What is the difference between the Expenses (in $) in Custom duties in 1998 and the Expenses (in $) in Other expenses in 2003?
Provide a short and direct response. -2.40e+09. What is the difference between the Expenses (in $) in Interest Payments in 1998 and the Expenses (in $) in Other expenses in 2003?
Provide a short and direct response. -2.38e+09. What is the difference between the Expenses (in $) of Salary of employees in 1999 and the Expenses (in $) of Custom duties in 2000?
Give a very brief answer. 4.44e+08. What is the difference between the Expenses (in $) of Salary of employees in 1999 and the Expenses (in $) of Interest Payments in 2000?
Make the answer very short. 4.42e+08. What is the difference between the Expenses (in $) of Salary of employees in 1999 and the Expenses (in $) of Other expenses in 2000?
Offer a very short reply. -1.37e+09. What is the difference between the Expenses (in $) in Custom duties in 1999 and the Expenses (in $) in Interest Payments in 2000?
Your response must be concise. -2.34e+06. What is the difference between the Expenses (in $) in Custom duties in 1999 and the Expenses (in $) in Other expenses in 2000?
Give a very brief answer. -1.81e+09. What is the difference between the Expenses (in $) in Interest Payments in 1999 and the Expenses (in $) in Other expenses in 2000?
Offer a terse response. -1.81e+09. What is the difference between the Expenses (in $) of Salary of employees in 1999 and the Expenses (in $) of Custom duties in 2001?
Provide a succinct answer. 4.44e+08. What is the difference between the Expenses (in $) in Salary of employees in 1999 and the Expenses (in $) in Interest Payments in 2001?
Ensure brevity in your answer.  4.44e+08. What is the difference between the Expenses (in $) in Salary of employees in 1999 and the Expenses (in $) in Other expenses in 2001?
Your response must be concise. -1.49e+09. What is the difference between the Expenses (in $) in Custom duties in 1999 and the Expenses (in $) in Interest Payments in 2001?
Your response must be concise. -3.40e+05. What is the difference between the Expenses (in $) of Custom duties in 1999 and the Expenses (in $) of Other expenses in 2001?
Give a very brief answer. -1.93e+09. What is the difference between the Expenses (in $) in Interest Payments in 1999 and the Expenses (in $) in Other expenses in 2001?
Keep it short and to the point. -1.92e+09. What is the difference between the Expenses (in $) in Salary of employees in 1999 and the Expenses (in $) in Custom duties in 2002?
Provide a succinct answer. 4.43e+08. What is the difference between the Expenses (in $) of Salary of employees in 1999 and the Expenses (in $) of Interest Payments in 2002?
Provide a short and direct response. 4.37e+08. What is the difference between the Expenses (in $) in Salary of employees in 1999 and the Expenses (in $) in Other expenses in 2002?
Provide a short and direct response. -1.70e+09. What is the difference between the Expenses (in $) in Custom duties in 1999 and the Expenses (in $) in Interest Payments in 2002?
Provide a succinct answer. -7.74e+06. What is the difference between the Expenses (in $) of Custom duties in 1999 and the Expenses (in $) of Other expenses in 2002?
Your answer should be very brief. -2.14e+09. What is the difference between the Expenses (in $) in Interest Payments in 1999 and the Expenses (in $) in Other expenses in 2002?
Your answer should be compact. -2.14e+09. What is the difference between the Expenses (in $) of Salary of employees in 1999 and the Expenses (in $) of Custom duties in 2003?
Give a very brief answer. 4.46e+08. What is the difference between the Expenses (in $) of Salary of employees in 1999 and the Expenses (in $) of Interest Payments in 2003?
Offer a terse response. 4.35e+08. What is the difference between the Expenses (in $) of Salary of employees in 1999 and the Expenses (in $) of Other expenses in 2003?
Offer a terse response. -1.95e+09. What is the difference between the Expenses (in $) in Custom duties in 1999 and the Expenses (in $) in Interest Payments in 2003?
Your response must be concise. -9.14e+06. What is the difference between the Expenses (in $) of Custom duties in 1999 and the Expenses (in $) of Other expenses in 2003?
Give a very brief answer. -2.40e+09. What is the difference between the Expenses (in $) of Interest Payments in 1999 and the Expenses (in $) of Other expenses in 2003?
Offer a terse response. -2.39e+09. What is the difference between the Expenses (in $) of Salary of employees in 2000 and the Expenses (in $) of Custom duties in 2001?
Offer a terse response. 4.72e+08. What is the difference between the Expenses (in $) in Salary of employees in 2000 and the Expenses (in $) in Interest Payments in 2001?
Offer a terse response. 4.72e+08. What is the difference between the Expenses (in $) in Salary of employees in 2000 and the Expenses (in $) in Other expenses in 2001?
Provide a short and direct response. -1.46e+09. What is the difference between the Expenses (in $) in Custom duties in 2000 and the Expenses (in $) in Interest Payments in 2001?
Provide a succinct answer. -4.00e+04. What is the difference between the Expenses (in $) of Custom duties in 2000 and the Expenses (in $) of Other expenses in 2001?
Ensure brevity in your answer.  -1.93e+09. What is the difference between the Expenses (in $) in Interest Payments in 2000 and the Expenses (in $) in Other expenses in 2001?
Your response must be concise. -1.93e+09. What is the difference between the Expenses (in $) in Salary of employees in 2000 and the Expenses (in $) in Custom duties in 2002?
Offer a very short reply. 4.71e+08. What is the difference between the Expenses (in $) in Salary of employees in 2000 and the Expenses (in $) in Interest Payments in 2002?
Offer a terse response. 4.65e+08. What is the difference between the Expenses (in $) of Salary of employees in 2000 and the Expenses (in $) of Other expenses in 2002?
Give a very brief answer. -1.67e+09. What is the difference between the Expenses (in $) of Custom duties in 2000 and the Expenses (in $) of Interest Payments in 2002?
Your answer should be compact. -7.44e+06. What is the difference between the Expenses (in $) in Custom duties in 2000 and the Expenses (in $) in Other expenses in 2002?
Ensure brevity in your answer.  -2.14e+09. What is the difference between the Expenses (in $) of Interest Payments in 2000 and the Expenses (in $) of Other expenses in 2002?
Your answer should be very brief. -2.14e+09. What is the difference between the Expenses (in $) of Salary of employees in 2000 and the Expenses (in $) of Custom duties in 2003?
Your answer should be very brief. 4.74e+08. What is the difference between the Expenses (in $) of Salary of employees in 2000 and the Expenses (in $) of Interest Payments in 2003?
Your answer should be compact. 4.63e+08. What is the difference between the Expenses (in $) of Salary of employees in 2000 and the Expenses (in $) of Other expenses in 2003?
Ensure brevity in your answer.  -1.92e+09. What is the difference between the Expenses (in $) in Custom duties in 2000 and the Expenses (in $) in Interest Payments in 2003?
Give a very brief answer. -8.84e+06. What is the difference between the Expenses (in $) in Custom duties in 2000 and the Expenses (in $) in Other expenses in 2003?
Your response must be concise. -2.40e+09. What is the difference between the Expenses (in $) of Interest Payments in 2000 and the Expenses (in $) of Other expenses in 2003?
Ensure brevity in your answer.  -2.40e+09. What is the difference between the Expenses (in $) of Salary of employees in 2001 and the Expenses (in $) of Custom duties in 2002?
Ensure brevity in your answer.  4.13e+08. What is the difference between the Expenses (in $) of Salary of employees in 2001 and the Expenses (in $) of Interest Payments in 2002?
Your answer should be compact. 4.06e+08. What is the difference between the Expenses (in $) of Salary of employees in 2001 and the Expenses (in $) of Other expenses in 2002?
Ensure brevity in your answer.  -1.73e+09. What is the difference between the Expenses (in $) in Custom duties in 2001 and the Expenses (in $) in Interest Payments in 2002?
Offer a very short reply. -7.55e+06. What is the difference between the Expenses (in $) of Custom duties in 2001 and the Expenses (in $) of Other expenses in 2002?
Provide a short and direct response. -2.14e+09. What is the difference between the Expenses (in $) of Interest Payments in 2001 and the Expenses (in $) of Other expenses in 2002?
Give a very brief answer. -2.14e+09. What is the difference between the Expenses (in $) in Salary of employees in 2001 and the Expenses (in $) in Custom duties in 2003?
Provide a succinct answer. 4.16e+08. What is the difference between the Expenses (in $) of Salary of employees in 2001 and the Expenses (in $) of Interest Payments in 2003?
Ensure brevity in your answer.  4.05e+08. What is the difference between the Expenses (in $) in Salary of employees in 2001 and the Expenses (in $) in Other expenses in 2003?
Your answer should be compact. -1.98e+09. What is the difference between the Expenses (in $) of Custom duties in 2001 and the Expenses (in $) of Interest Payments in 2003?
Offer a very short reply. -8.95e+06. What is the difference between the Expenses (in $) of Custom duties in 2001 and the Expenses (in $) of Other expenses in 2003?
Your response must be concise. -2.40e+09. What is the difference between the Expenses (in $) in Interest Payments in 2001 and the Expenses (in $) in Other expenses in 2003?
Provide a short and direct response. -2.40e+09. What is the difference between the Expenses (in $) of Salary of employees in 2002 and the Expenses (in $) of Custom duties in 2003?
Keep it short and to the point. 4.66e+08. What is the difference between the Expenses (in $) of Salary of employees in 2002 and the Expenses (in $) of Interest Payments in 2003?
Your answer should be compact. 4.56e+08. What is the difference between the Expenses (in $) of Salary of employees in 2002 and the Expenses (in $) of Other expenses in 2003?
Your response must be concise. -1.93e+09. What is the difference between the Expenses (in $) of Custom duties in 2002 and the Expenses (in $) of Interest Payments in 2003?
Offer a terse response. -7.99e+06. What is the difference between the Expenses (in $) of Custom duties in 2002 and the Expenses (in $) of Other expenses in 2003?
Your response must be concise. -2.40e+09. What is the difference between the Expenses (in $) in Interest Payments in 2002 and the Expenses (in $) in Other expenses in 2003?
Provide a succinct answer. -2.39e+09. What is the average Expenses (in $) in Salary of employees per year?
Your response must be concise. 3.85e+08. What is the average Expenses (in $) in Custom duties per year?
Your answer should be very brief. 1.34e+06. What is the average Expenses (in $) in Interest Payments per year?
Give a very brief answer. 9.80e+06. What is the average Expenses (in $) in Other expenses per year?
Your response must be concise. 1.68e+09. In the year 1995, what is the difference between the Expenses (in $) of Salary of employees and Expenses (in $) of Custom duties?
Offer a very short reply. 2.12e+08. In the year 1995, what is the difference between the Expenses (in $) of Salary of employees and Expenses (in $) of Interest Payments?
Give a very brief answer. 2.00e+08. In the year 1995, what is the difference between the Expenses (in $) in Salary of employees and Expenses (in $) in Other expenses?
Your answer should be very brief. -6.94e+08. In the year 1995, what is the difference between the Expenses (in $) in Custom duties and Expenses (in $) in Interest Payments?
Give a very brief answer. -1.22e+07. In the year 1995, what is the difference between the Expenses (in $) of Custom duties and Expenses (in $) of Other expenses?
Give a very brief answer. -9.06e+08. In the year 1995, what is the difference between the Expenses (in $) in Interest Payments and Expenses (in $) in Other expenses?
Provide a succinct answer. -8.94e+08. In the year 1996, what is the difference between the Expenses (in $) in Salary of employees and Expenses (in $) in Custom duties?
Provide a succinct answer. 2.59e+08. In the year 1996, what is the difference between the Expenses (in $) in Salary of employees and Expenses (in $) in Interest Payments?
Offer a very short reply. 2.45e+08. In the year 1996, what is the difference between the Expenses (in $) in Salary of employees and Expenses (in $) in Other expenses?
Your response must be concise. -1.03e+09. In the year 1996, what is the difference between the Expenses (in $) in Custom duties and Expenses (in $) in Interest Payments?
Keep it short and to the point. -1.45e+07. In the year 1996, what is the difference between the Expenses (in $) in Custom duties and Expenses (in $) in Other expenses?
Keep it short and to the point. -1.29e+09. In the year 1996, what is the difference between the Expenses (in $) of Interest Payments and Expenses (in $) of Other expenses?
Your response must be concise. -1.28e+09. In the year 1997, what is the difference between the Expenses (in $) of Salary of employees and Expenses (in $) of Custom duties?
Your answer should be compact. 3.07e+08. In the year 1997, what is the difference between the Expenses (in $) in Salary of employees and Expenses (in $) in Interest Payments?
Provide a succinct answer. 2.98e+08. In the year 1997, what is the difference between the Expenses (in $) in Salary of employees and Expenses (in $) in Other expenses?
Provide a succinct answer. -1.03e+09. In the year 1997, what is the difference between the Expenses (in $) in Custom duties and Expenses (in $) in Interest Payments?
Ensure brevity in your answer.  -8.26e+06. In the year 1997, what is the difference between the Expenses (in $) in Custom duties and Expenses (in $) in Other expenses?
Offer a terse response. -1.33e+09. In the year 1997, what is the difference between the Expenses (in $) in Interest Payments and Expenses (in $) in Other expenses?
Your answer should be very brief. -1.32e+09. In the year 1998, what is the difference between the Expenses (in $) of Salary of employees and Expenses (in $) of Custom duties?
Make the answer very short. 3.59e+08. In the year 1998, what is the difference between the Expenses (in $) in Salary of employees and Expenses (in $) in Interest Payments?
Ensure brevity in your answer.  3.44e+08. In the year 1998, what is the difference between the Expenses (in $) of Salary of employees and Expenses (in $) of Other expenses?
Your answer should be very brief. -1.20e+09. In the year 1998, what is the difference between the Expenses (in $) in Custom duties and Expenses (in $) in Interest Payments?
Provide a short and direct response. -1.54e+07. In the year 1998, what is the difference between the Expenses (in $) of Custom duties and Expenses (in $) of Other expenses?
Your answer should be very brief. -1.56e+09. In the year 1998, what is the difference between the Expenses (in $) of Interest Payments and Expenses (in $) of Other expenses?
Your answer should be very brief. -1.55e+09. In the year 1999, what is the difference between the Expenses (in $) in Salary of employees and Expenses (in $) in Custom duties?
Offer a terse response. 4.44e+08. In the year 1999, what is the difference between the Expenses (in $) in Salary of employees and Expenses (in $) in Interest Payments?
Your answer should be very brief. 4.38e+08. In the year 1999, what is the difference between the Expenses (in $) of Salary of employees and Expenses (in $) of Other expenses?
Provide a short and direct response. -1.30e+09. In the year 1999, what is the difference between the Expenses (in $) in Custom duties and Expenses (in $) in Interest Payments?
Give a very brief answer. -6.44e+06. In the year 1999, what is the difference between the Expenses (in $) in Custom duties and Expenses (in $) in Other expenses?
Make the answer very short. -1.75e+09. In the year 1999, what is the difference between the Expenses (in $) of Interest Payments and Expenses (in $) of Other expenses?
Provide a succinct answer. -1.74e+09. In the year 2000, what is the difference between the Expenses (in $) in Salary of employees and Expenses (in $) in Custom duties?
Provide a short and direct response. 4.72e+08. In the year 2000, what is the difference between the Expenses (in $) of Salary of employees and Expenses (in $) of Interest Payments?
Provide a short and direct response. 4.70e+08. In the year 2000, what is the difference between the Expenses (in $) of Salary of employees and Expenses (in $) of Other expenses?
Ensure brevity in your answer.  -1.34e+09. In the year 2000, what is the difference between the Expenses (in $) in Custom duties and Expenses (in $) in Interest Payments?
Your answer should be compact. -2.04e+06. In the year 2000, what is the difference between the Expenses (in $) of Custom duties and Expenses (in $) of Other expenses?
Keep it short and to the point. -1.81e+09. In the year 2000, what is the difference between the Expenses (in $) in Interest Payments and Expenses (in $) in Other expenses?
Make the answer very short. -1.81e+09. In the year 2001, what is the difference between the Expenses (in $) of Salary of employees and Expenses (in $) of Custom duties?
Ensure brevity in your answer.  4.14e+08. In the year 2001, what is the difference between the Expenses (in $) of Salary of employees and Expenses (in $) of Interest Payments?
Make the answer very short. 4.14e+08. In the year 2001, what is the difference between the Expenses (in $) of Salary of employees and Expenses (in $) of Other expenses?
Offer a terse response. -1.52e+09. In the year 2001, what is the difference between the Expenses (in $) in Custom duties and Expenses (in $) in Interest Payments?
Your answer should be compact. -1.50e+05. In the year 2001, what is the difference between the Expenses (in $) in Custom duties and Expenses (in $) in Other expenses?
Your response must be concise. -1.93e+09. In the year 2001, what is the difference between the Expenses (in $) of Interest Payments and Expenses (in $) of Other expenses?
Offer a terse response. -1.93e+09. In the year 2002, what is the difference between the Expenses (in $) in Salary of employees and Expenses (in $) in Custom duties?
Offer a very short reply. 4.64e+08. In the year 2002, what is the difference between the Expenses (in $) in Salary of employees and Expenses (in $) in Interest Payments?
Offer a very short reply. 4.57e+08. In the year 2002, what is the difference between the Expenses (in $) in Salary of employees and Expenses (in $) in Other expenses?
Give a very brief answer. -1.68e+09. In the year 2002, what is the difference between the Expenses (in $) of Custom duties and Expenses (in $) of Interest Payments?
Provide a short and direct response. -6.59e+06. In the year 2002, what is the difference between the Expenses (in $) of Custom duties and Expenses (in $) of Other expenses?
Offer a very short reply. -2.14e+09. In the year 2002, what is the difference between the Expenses (in $) in Interest Payments and Expenses (in $) in Other expenses?
Give a very brief answer. -2.14e+09. In the year 2003, what is the difference between the Expenses (in $) of Salary of employees and Expenses (in $) of Custom duties?
Your answer should be compact. 5.25e+08. In the year 2003, what is the difference between the Expenses (in $) in Salary of employees and Expenses (in $) in Interest Payments?
Make the answer very short. 5.14e+08. In the year 2003, what is the difference between the Expenses (in $) in Salary of employees and Expenses (in $) in Other expenses?
Provide a short and direct response. -1.87e+09. In the year 2003, what is the difference between the Expenses (in $) of Custom duties and Expenses (in $) of Interest Payments?
Your answer should be compact. -1.06e+07. In the year 2003, what is the difference between the Expenses (in $) of Custom duties and Expenses (in $) of Other expenses?
Ensure brevity in your answer.  -2.40e+09. In the year 2003, what is the difference between the Expenses (in $) in Interest Payments and Expenses (in $) in Other expenses?
Keep it short and to the point. -2.39e+09. What is the ratio of the Expenses (in $) in Salary of employees in 1995 to that in 1996?
Offer a terse response. 0.82. What is the ratio of the Expenses (in $) of Custom duties in 1995 to that in 1996?
Your response must be concise. 16.67. What is the ratio of the Expenses (in $) in Interest Payments in 1995 to that in 1996?
Your answer should be compact. 0.88. What is the ratio of the Expenses (in $) of Other expenses in 1995 to that in 1996?
Give a very brief answer. 0.7. What is the ratio of the Expenses (in $) in Salary of employees in 1995 to that in 1997?
Your answer should be very brief. 0.69. What is the ratio of the Expenses (in $) of Interest Payments in 1995 to that in 1997?
Offer a very short reply. 1.53. What is the ratio of the Expenses (in $) of Other expenses in 1995 to that in 1997?
Your answer should be compact. 0.68. What is the ratio of the Expenses (in $) in Salary of employees in 1995 to that in 1998?
Your response must be concise. 0.59. What is the ratio of the Expenses (in $) in Interest Payments in 1995 to that in 1998?
Give a very brief answer. 0.82. What is the ratio of the Expenses (in $) of Other expenses in 1995 to that in 1998?
Your answer should be very brief. 0.58. What is the ratio of the Expenses (in $) in Salary of employees in 1995 to that in 1999?
Provide a succinct answer. 0.48. What is the ratio of the Expenses (in $) of Custom duties in 1995 to that in 1999?
Provide a succinct answer. 0.22. What is the ratio of the Expenses (in $) of Interest Payments in 1995 to that in 1999?
Your answer should be compact. 1.46. What is the ratio of the Expenses (in $) in Other expenses in 1995 to that in 1999?
Offer a very short reply. 0.52. What is the ratio of the Expenses (in $) of Salary of employees in 1995 to that in 2000?
Offer a terse response. 0.45. What is the ratio of the Expenses (in $) in Custom duties in 1995 to that in 2000?
Your answer should be very brief. 0.2. What is the ratio of the Expenses (in $) in Interest Payments in 1995 to that in 2000?
Make the answer very short. 2.76. What is the ratio of the Expenses (in $) of Other expenses in 1995 to that in 2000?
Offer a very short reply. 0.5. What is the ratio of the Expenses (in $) of Salary of employees in 1995 to that in 2001?
Offer a terse response. 0.51. What is the ratio of the Expenses (in $) of Custom duties in 1995 to that in 2001?
Offer a terse response. 0.2. What is the ratio of the Expenses (in $) of Interest Payments in 1995 to that in 2001?
Your response must be concise. 4.88. What is the ratio of the Expenses (in $) of Other expenses in 1995 to that in 2001?
Your answer should be compact. 0.47. What is the ratio of the Expenses (in $) of Salary of employees in 1995 to that in 2002?
Give a very brief answer. 0.46. What is the ratio of the Expenses (in $) of Custom duties in 1995 to that in 2002?
Give a very brief answer. 0.15. What is the ratio of the Expenses (in $) in Interest Payments in 1995 to that in 2002?
Provide a succinct answer. 1.27. What is the ratio of the Expenses (in $) in Other expenses in 1995 to that in 2002?
Give a very brief answer. 0.42. What is the ratio of the Expenses (in $) of Salary of employees in 1995 to that in 2003?
Make the answer very short. 0.4. What is the ratio of the Expenses (in $) of Custom duties in 1995 to that in 2003?
Make the answer very short. 0.64. What is the ratio of the Expenses (in $) of Interest Payments in 1995 to that in 2003?
Offer a terse response. 1.11. What is the ratio of the Expenses (in $) of Other expenses in 1995 to that in 2003?
Your answer should be compact. 0.38. What is the ratio of the Expenses (in $) of Salary of employees in 1996 to that in 1997?
Your answer should be very brief. 0.84. What is the ratio of the Expenses (in $) of Custom duties in 1996 to that in 1997?
Your response must be concise. 0.75. What is the ratio of the Expenses (in $) in Interest Payments in 1996 to that in 1997?
Provide a short and direct response. 1.75. What is the ratio of the Expenses (in $) of Other expenses in 1996 to that in 1997?
Make the answer very short. 0.97. What is the ratio of the Expenses (in $) of Salary of employees in 1996 to that in 1998?
Your answer should be compact. 0.72. What is the ratio of the Expenses (in $) in Custom duties in 1996 to that in 1998?
Offer a very short reply. 3. What is the ratio of the Expenses (in $) of Interest Payments in 1996 to that in 1998?
Your answer should be compact. 0.94. What is the ratio of the Expenses (in $) in Other expenses in 1996 to that in 1998?
Offer a terse response. 0.83. What is the ratio of the Expenses (in $) in Salary of employees in 1996 to that in 1999?
Ensure brevity in your answer.  0.58. What is the ratio of the Expenses (in $) in Custom duties in 1996 to that in 1999?
Your response must be concise. 0.01. What is the ratio of the Expenses (in $) in Other expenses in 1996 to that in 1999?
Ensure brevity in your answer.  0.74. What is the ratio of the Expenses (in $) of Salary of employees in 1996 to that in 2000?
Provide a succinct answer. 0.55. What is the ratio of the Expenses (in $) of Custom duties in 1996 to that in 2000?
Ensure brevity in your answer.  0.01. What is the ratio of the Expenses (in $) in Interest Payments in 1996 to that in 2000?
Keep it short and to the point. 3.15. What is the ratio of the Expenses (in $) of Other expenses in 1996 to that in 2000?
Ensure brevity in your answer.  0.71. What is the ratio of the Expenses (in $) of Salary of employees in 1996 to that in 2001?
Your answer should be very brief. 0.62. What is the ratio of the Expenses (in $) in Custom duties in 1996 to that in 2001?
Provide a short and direct response. 0.01. What is the ratio of the Expenses (in $) in Interest Payments in 1996 to that in 2001?
Your response must be concise. 5.58. What is the ratio of the Expenses (in $) of Other expenses in 1996 to that in 2001?
Provide a short and direct response. 0.67. What is the ratio of the Expenses (in $) of Salary of employees in 1996 to that in 2002?
Your answer should be very brief. 0.56. What is the ratio of the Expenses (in $) in Custom duties in 1996 to that in 2002?
Your answer should be compact. 0.01. What is the ratio of the Expenses (in $) of Interest Payments in 1996 to that in 2002?
Provide a succinct answer. 1.45. What is the ratio of the Expenses (in $) of Other expenses in 1996 to that in 2002?
Your answer should be compact. 0.6. What is the ratio of the Expenses (in $) of Salary of employees in 1996 to that in 2003?
Offer a terse response. 0.49. What is the ratio of the Expenses (in $) of Custom duties in 1996 to that in 2003?
Provide a succinct answer. 0.04. What is the ratio of the Expenses (in $) in Interest Payments in 1996 to that in 2003?
Make the answer very short. 1.27. What is the ratio of the Expenses (in $) of Other expenses in 1996 to that in 2003?
Offer a very short reply. 0.54. What is the ratio of the Expenses (in $) in Salary of employees in 1997 to that in 1998?
Provide a short and direct response. 0.85. What is the ratio of the Expenses (in $) of Interest Payments in 1997 to that in 1998?
Provide a short and direct response. 0.54. What is the ratio of the Expenses (in $) of Other expenses in 1997 to that in 1998?
Keep it short and to the point. 0.85. What is the ratio of the Expenses (in $) of Salary of employees in 1997 to that in 1999?
Offer a terse response. 0.69. What is the ratio of the Expenses (in $) in Custom duties in 1997 to that in 1999?
Your answer should be compact. 0.02. What is the ratio of the Expenses (in $) of Interest Payments in 1997 to that in 1999?
Offer a very short reply. 0.95. What is the ratio of the Expenses (in $) in Other expenses in 1997 to that in 1999?
Your answer should be very brief. 0.76. What is the ratio of the Expenses (in $) of Salary of employees in 1997 to that in 2000?
Offer a terse response. 0.65. What is the ratio of the Expenses (in $) of Custom duties in 1997 to that in 2000?
Provide a short and direct response. 0.02. What is the ratio of the Expenses (in $) of Interest Payments in 1997 to that in 2000?
Make the answer very short. 1.8. What is the ratio of the Expenses (in $) of Other expenses in 1997 to that in 2000?
Make the answer very short. 0.73. What is the ratio of the Expenses (in $) in Salary of employees in 1997 to that in 2001?
Your answer should be compact. 0.74. What is the ratio of the Expenses (in $) in Custom duties in 1997 to that in 2001?
Make the answer very short. 0.02. What is the ratio of the Expenses (in $) in Interest Payments in 1997 to that in 2001?
Give a very brief answer. 3.19. What is the ratio of the Expenses (in $) in Other expenses in 1997 to that in 2001?
Provide a short and direct response. 0.69. What is the ratio of the Expenses (in $) in Salary of employees in 1997 to that in 2002?
Your response must be concise. 0.66. What is the ratio of the Expenses (in $) of Custom duties in 1997 to that in 2002?
Make the answer very short. 0.01. What is the ratio of the Expenses (in $) of Interest Payments in 1997 to that in 2002?
Keep it short and to the point. 0.83. What is the ratio of the Expenses (in $) in Other expenses in 1997 to that in 2002?
Keep it short and to the point. 0.62. What is the ratio of the Expenses (in $) in Salary of employees in 1997 to that in 2003?
Your response must be concise. 0.58. What is the ratio of the Expenses (in $) in Custom duties in 1997 to that in 2003?
Give a very brief answer. 0.05. What is the ratio of the Expenses (in $) of Interest Payments in 1997 to that in 2003?
Offer a very short reply. 0.73. What is the ratio of the Expenses (in $) in Other expenses in 1997 to that in 2003?
Ensure brevity in your answer.  0.56. What is the ratio of the Expenses (in $) in Salary of employees in 1998 to that in 1999?
Your answer should be very brief. 0.8. What is the ratio of the Expenses (in $) in Custom duties in 1998 to that in 1999?
Keep it short and to the point. 0. What is the ratio of the Expenses (in $) in Interest Payments in 1998 to that in 1999?
Provide a succinct answer. 1.77. What is the ratio of the Expenses (in $) in Other expenses in 1998 to that in 1999?
Offer a terse response. 0.89. What is the ratio of the Expenses (in $) of Salary of employees in 1998 to that in 2000?
Give a very brief answer. 0.76. What is the ratio of the Expenses (in $) of Custom duties in 1998 to that in 2000?
Make the answer very short. 0. What is the ratio of the Expenses (in $) in Interest Payments in 1998 to that in 2000?
Give a very brief answer. 3.35. What is the ratio of the Expenses (in $) of Other expenses in 1998 to that in 2000?
Provide a short and direct response. 0.86. What is the ratio of the Expenses (in $) in Salary of employees in 1998 to that in 2001?
Your response must be concise. 0.86. What is the ratio of the Expenses (in $) of Custom duties in 1998 to that in 2001?
Your answer should be very brief. 0. What is the ratio of the Expenses (in $) of Interest Payments in 1998 to that in 2001?
Give a very brief answer. 5.92. What is the ratio of the Expenses (in $) in Other expenses in 1998 to that in 2001?
Give a very brief answer. 0.81. What is the ratio of the Expenses (in $) of Salary of employees in 1998 to that in 2002?
Give a very brief answer. 0.77. What is the ratio of the Expenses (in $) in Custom duties in 1998 to that in 2002?
Ensure brevity in your answer.  0. What is the ratio of the Expenses (in $) of Interest Payments in 1998 to that in 2002?
Make the answer very short. 1.54. What is the ratio of the Expenses (in $) in Other expenses in 1998 to that in 2002?
Keep it short and to the point. 0.73. What is the ratio of the Expenses (in $) of Salary of employees in 1998 to that in 2003?
Offer a terse response. 0.68. What is the ratio of the Expenses (in $) of Custom duties in 1998 to that in 2003?
Give a very brief answer. 0.01. What is the ratio of the Expenses (in $) in Interest Payments in 1998 to that in 2003?
Offer a very short reply. 1.35. What is the ratio of the Expenses (in $) of Other expenses in 1998 to that in 2003?
Offer a terse response. 0.65. What is the ratio of the Expenses (in $) of Salary of employees in 1999 to that in 2000?
Ensure brevity in your answer.  0.94. What is the ratio of the Expenses (in $) in Custom duties in 1999 to that in 2000?
Provide a succinct answer. 0.88. What is the ratio of the Expenses (in $) in Interest Payments in 1999 to that in 2000?
Your answer should be compact. 1.89. What is the ratio of the Expenses (in $) of Other expenses in 1999 to that in 2000?
Provide a succinct answer. 0.96. What is the ratio of the Expenses (in $) in Salary of employees in 1999 to that in 2001?
Give a very brief answer. 1.07. What is the ratio of the Expenses (in $) of Custom duties in 1999 to that in 2001?
Provide a succinct answer. 0.92. What is the ratio of the Expenses (in $) in Interest Payments in 1999 to that in 2001?
Your answer should be compact. 3.35. What is the ratio of the Expenses (in $) in Other expenses in 1999 to that in 2001?
Keep it short and to the point. 0.9. What is the ratio of the Expenses (in $) of Salary of employees in 1999 to that in 2002?
Provide a succinct answer. 0.96. What is the ratio of the Expenses (in $) in Custom duties in 1999 to that in 2002?
Make the answer very short. 0.66. What is the ratio of the Expenses (in $) of Interest Payments in 1999 to that in 2002?
Your answer should be very brief. 0.87. What is the ratio of the Expenses (in $) of Other expenses in 1999 to that in 2002?
Your response must be concise. 0.82. What is the ratio of the Expenses (in $) of Salary of employees in 1999 to that in 2003?
Give a very brief answer. 0.85. What is the ratio of the Expenses (in $) of Custom duties in 1999 to that in 2003?
Your answer should be compact. 2.9. What is the ratio of the Expenses (in $) of Interest Payments in 1999 to that in 2003?
Your response must be concise. 0.76. What is the ratio of the Expenses (in $) in Other expenses in 1999 to that in 2003?
Offer a terse response. 0.73. What is the ratio of the Expenses (in $) of Salary of employees in 2000 to that in 2001?
Your answer should be compact. 1.14. What is the ratio of the Expenses (in $) in Custom duties in 2000 to that in 2001?
Your response must be concise. 1.04. What is the ratio of the Expenses (in $) in Interest Payments in 2000 to that in 2001?
Offer a terse response. 1.77. What is the ratio of the Expenses (in $) of Other expenses in 2000 to that in 2001?
Give a very brief answer. 0.94. What is the ratio of the Expenses (in $) of Salary of employees in 2000 to that in 2002?
Provide a short and direct response. 1.02. What is the ratio of the Expenses (in $) of Custom duties in 2000 to that in 2002?
Offer a very short reply. 0.75. What is the ratio of the Expenses (in $) in Interest Payments in 2000 to that in 2002?
Make the answer very short. 0.46. What is the ratio of the Expenses (in $) of Other expenses in 2000 to that in 2002?
Ensure brevity in your answer.  0.85. What is the ratio of the Expenses (in $) in Salary of employees in 2000 to that in 2003?
Keep it short and to the point. 0.9. What is the ratio of the Expenses (in $) in Custom duties in 2000 to that in 2003?
Make the answer very short. 3.28. What is the ratio of the Expenses (in $) in Interest Payments in 2000 to that in 2003?
Offer a terse response. 0.4. What is the ratio of the Expenses (in $) of Other expenses in 2000 to that in 2003?
Give a very brief answer. 0.76. What is the ratio of the Expenses (in $) of Salary of employees in 2001 to that in 2002?
Give a very brief answer. 0.89. What is the ratio of the Expenses (in $) of Custom duties in 2001 to that in 2002?
Offer a terse response. 0.72. What is the ratio of the Expenses (in $) in Interest Payments in 2001 to that in 2002?
Offer a terse response. 0.26. What is the ratio of the Expenses (in $) in Other expenses in 2001 to that in 2002?
Offer a terse response. 0.9. What is the ratio of the Expenses (in $) in Salary of employees in 2001 to that in 2003?
Keep it short and to the point. 0.79. What is the ratio of the Expenses (in $) of Custom duties in 2001 to that in 2003?
Your answer should be very brief. 3.14. What is the ratio of the Expenses (in $) of Interest Payments in 2001 to that in 2003?
Your answer should be very brief. 0.23. What is the ratio of the Expenses (in $) in Other expenses in 2001 to that in 2003?
Ensure brevity in your answer.  0.81. What is the ratio of the Expenses (in $) of Salary of employees in 2002 to that in 2003?
Your response must be concise. 0.89. What is the ratio of the Expenses (in $) of Custom duties in 2002 to that in 2003?
Offer a very short reply. 4.37. What is the ratio of the Expenses (in $) of Interest Payments in 2002 to that in 2003?
Provide a short and direct response. 0.88. What is the ratio of the Expenses (in $) of Other expenses in 2002 to that in 2003?
Offer a terse response. 0.89. What is the difference between the highest and the second highest Expenses (in $) of Salary of employees?
Give a very brief answer. 5.12e+07. What is the difference between the highest and the second highest Expenses (in $) of Custom duties?
Offer a very short reply. 8.50e+05. What is the difference between the highest and the second highest Expenses (in $) in Other expenses?
Your response must be concise. 2.54e+08. What is the difference between the highest and the lowest Expenses (in $) in Salary of employees?
Give a very brief answer. 3.13e+08. What is the difference between the highest and the lowest Expenses (in $) in Custom duties?
Give a very brief answer. 3.40e+06. What is the difference between the highest and the lowest Expenses (in $) in Interest Payments?
Give a very brief answer. 1.28e+07. What is the difference between the highest and the lowest Expenses (in $) in Other expenses?
Provide a succinct answer. 1.49e+09. 